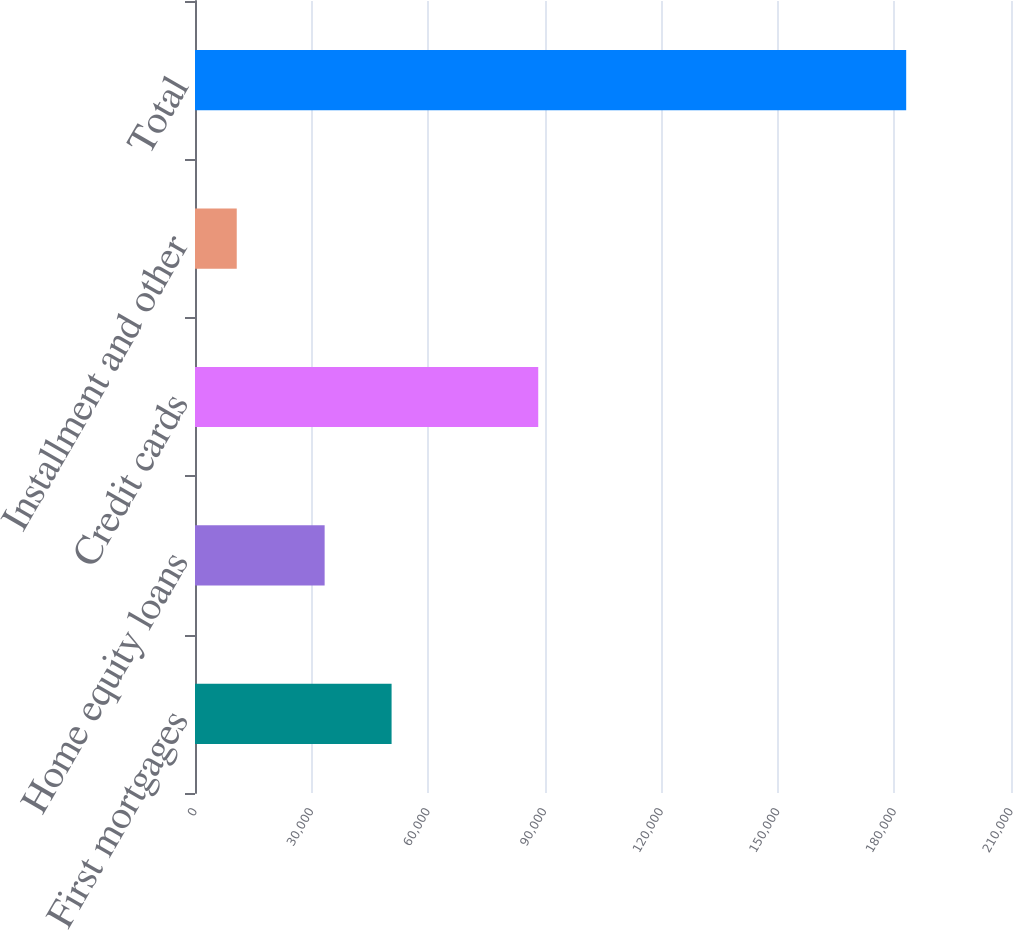Convert chart. <chart><loc_0><loc_0><loc_500><loc_500><bar_chart><fcel>First mortgages<fcel>Home equity loans<fcel>Credit cards<fcel>Installment and other<fcel>Total<nl><fcel>50591.4<fcel>33363<fcel>88332<fcel>10743<fcel>183027<nl></chart> 